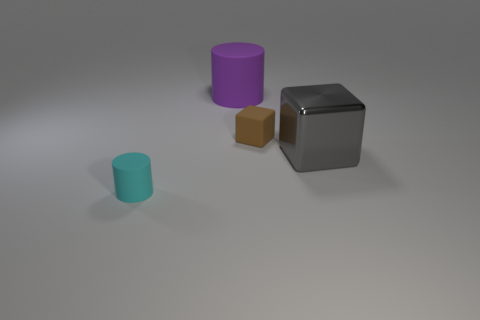Could you estimate the scale of the objects in this image? Without reference points for size, it's difficult to accurately estimate their scale, but given their simplicity, they might represent small desk objects such as paperweights or decorative items. 